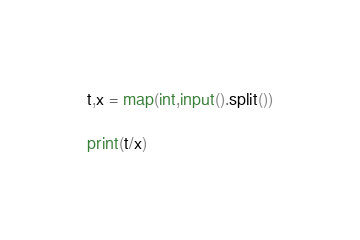Convert code to text. <code><loc_0><loc_0><loc_500><loc_500><_Python_>
t,x = map(int,input().split())

print(t/x)
</code> 